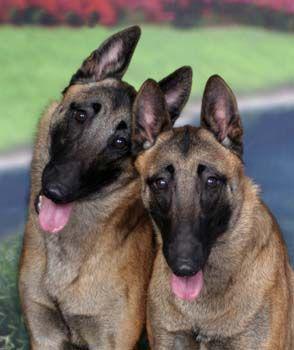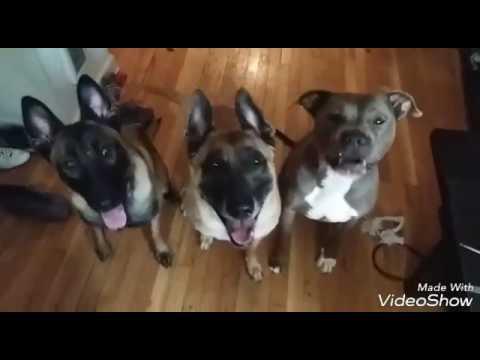The first image is the image on the left, the second image is the image on the right. For the images displayed, is the sentence "Each image contains a single german shepherd, and each dog wears a leash." factually correct? Answer yes or no. No. The first image is the image on the left, the second image is the image on the right. Considering the images on both sides, is "There are two dogs with pointed ears and tongues sticking out." valid? Answer yes or no. No. 